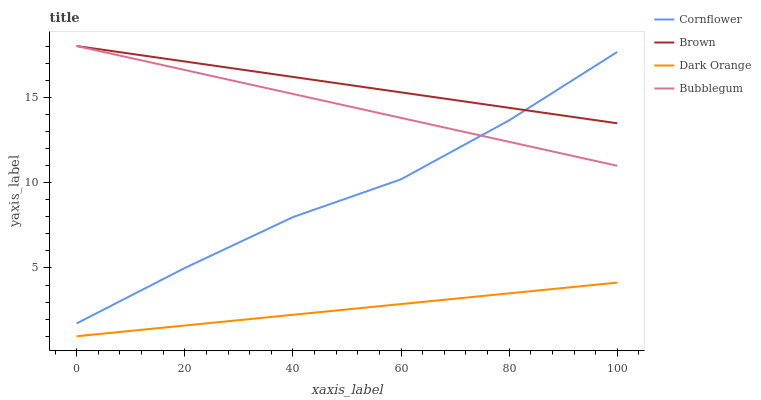Does Dark Orange have the minimum area under the curve?
Answer yes or no. Yes. Does Brown have the maximum area under the curve?
Answer yes or no. Yes. Does Cornflower have the minimum area under the curve?
Answer yes or no. No. Does Cornflower have the maximum area under the curve?
Answer yes or no. No. Is Dark Orange the smoothest?
Answer yes or no. Yes. Is Cornflower the roughest?
Answer yes or no. Yes. Is Bubblegum the smoothest?
Answer yes or no. No. Is Bubblegum the roughest?
Answer yes or no. No. Does Dark Orange have the lowest value?
Answer yes or no. Yes. Does Cornflower have the lowest value?
Answer yes or no. No. Does Brown have the highest value?
Answer yes or no. Yes. Does Cornflower have the highest value?
Answer yes or no. No. Is Dark Orange less than Brown?
Answer yes or no. Yes. Is Cornflower greater than Dark Orange?
Answer yes or no. Yes. Does Brown intersect Cornflower?
Answer yes or no. Yes. Is Brown less than Cornflower?
Answer yes or no. No. Is Brown greater than Cornflower?
Answer yes or no. No. Does Dark Orange intersect Brown?
Answer yes or no. No. 